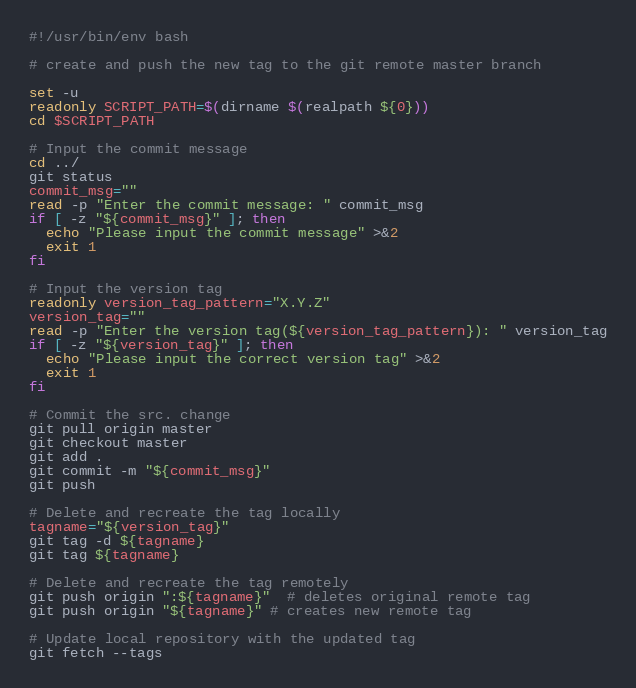<code> <loc_0><loc_0><loc_500><loc_500><_Bash_>#!/usr/bin/env bash

# create and push the new tag to the git remote master branch

set -u
readonly SCRIPT_PATH=$(dirname $(realpath ${0}))
cd $SCRIPT_PATH

# Input the commit message
cd ../
git status
commit_msg=""
read -p "Enter the commit message: " commit_msg
if [ -z "${commit_msg}" ]; then
  echo "Please input the commit message" >&2
  exit 1
fi

# Input the version tag
readonly version_tag_pattern="X.Y.Z"
version_tag=""
read -p "Enter the version tag(${version_tag_pattern}): " version_tag
if [ -z "${version_tag}" ]; then
  echo "Please input the correct version tag" >&2
  exit 1
fi

# Commit the src. change
git pull origin master
git checkout master
git add .
git commit -m "${commit_msg}"
git push

# Delete and recreate the tag locally
tagname="${version_tag}"
git tag -d ${tagname}
git tag ${tagname}

# Delete and recreate the tag remotely
git push origin ":${tagname}"  # deletes original remote tag
git push origin "${tagname}" # creates new remote tag

# Update local repository with the updated tag
git fetch --tags</code> 